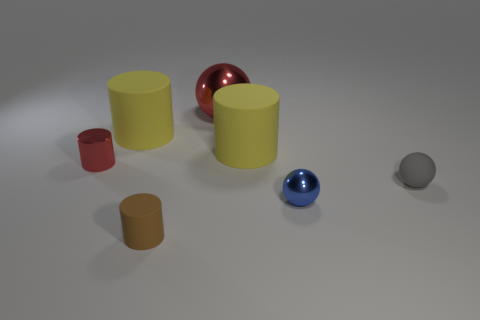Are there more small blue things than tiny yellow blocks?
Provide a succinct answer. Yes. Do the tiny metal thing behind the small gray ball and the small brown object have the same shape?
Give a very brief answer. Yes. What number of small objects are both behind the tiny gray ball and to the right of the blue metallic ball?
Your response must be concise. 0. How many large yellow matte things have the same shape as the tiny gray object?
Your response must be concise. 0. There is a tiny matte thing to the right of the red ball that is left of the blue ball; what is its color?
Offer a terse response. Gray. There is a small brown matte thing; is its shape the same as the small shiny object that is behind the tiny blue sphere?
Your answer should be compact. Yes. What is the material of the large yellow cylinder behind the large matte cylinder that is right of the cylinder that is in front of the tiny red cylinder?
Your answer should be compact. Rubber. Is there a brown rubber cylinder of the same size as the gray thing?
Give a very brief answer. Yes. There is a red object that is the same material as the large sphere; what is its size?
Offer a terse response. Small. The tiny red object has what shape?
Make the answer very short. Cylinder. 